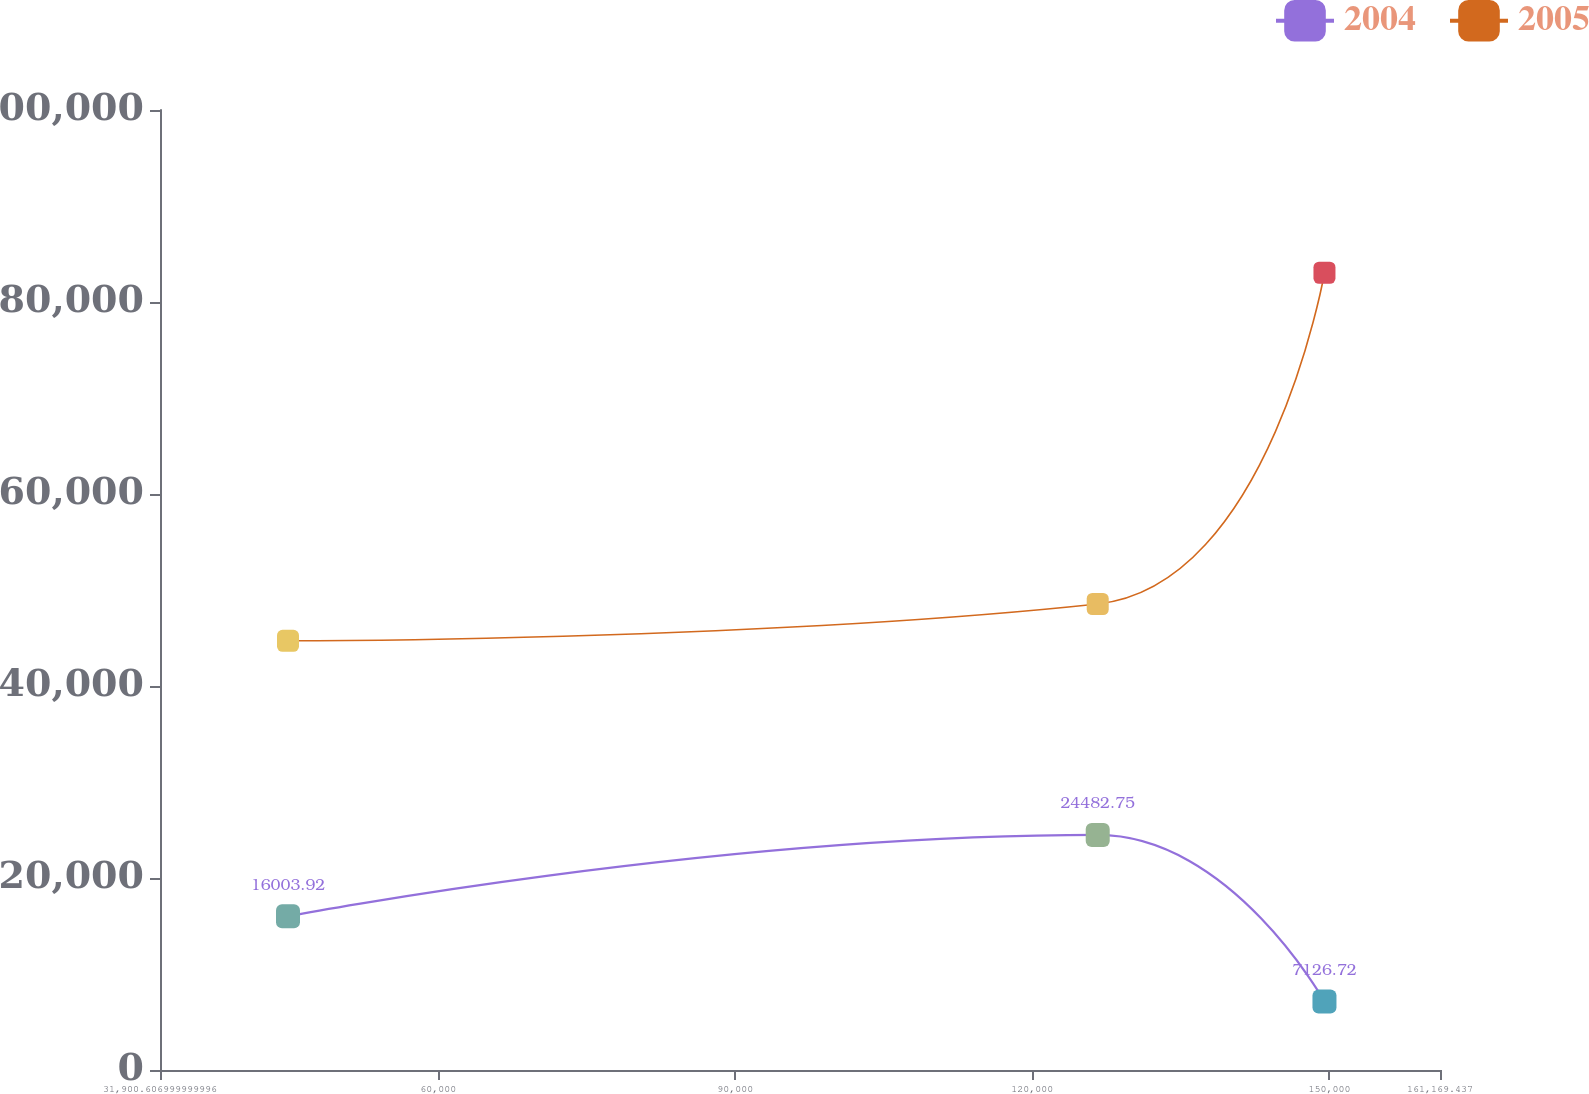<chart> <loc_0><loc_0><loc_500><loc_500><line_chart><ecel><fcel>2004<fcel>2005<nl><fcel>44827.5<fcel>16003.9<fcel>44708.9<nl><fcel>126602<fcel>24482.8<fcel>48542.7<nl><fcel>149501<fcel>7126.72<fcel>83046.6<nl><fcel>174096<fcel>61263.1<fcel>66016.1<nl></chart> 